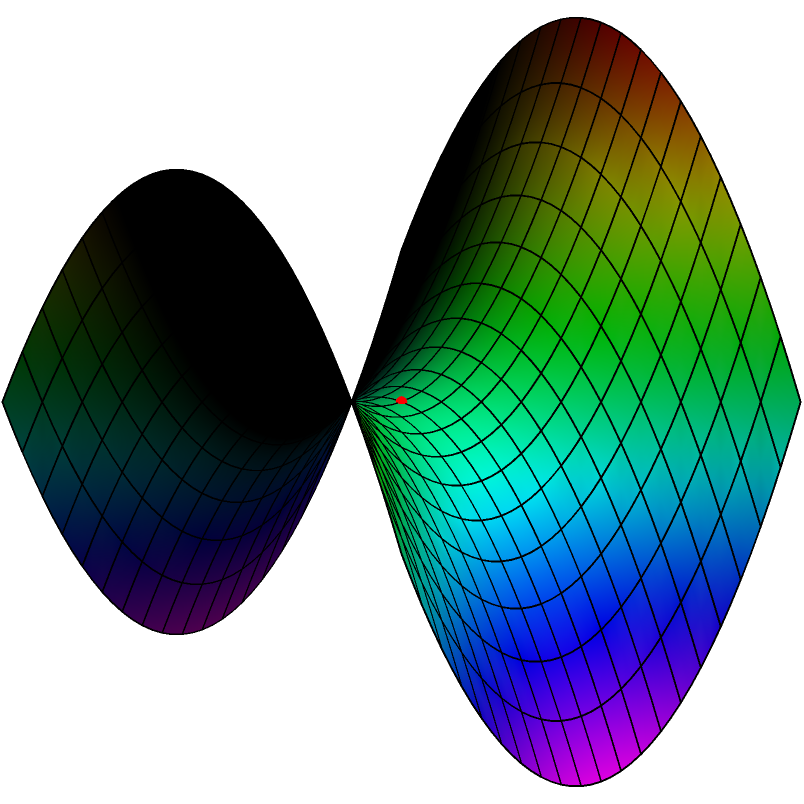On this saddle-shaped surface representing Mylène Farmer's career, point A (in red) represents her debut, and point B (in blue) represents her current status. Which path between these points would best symbolize her journey, considering the non-Euclidean geometry of her career trajectory? To answer this question, we need to consider the principles of non-Euclidean geometry on a saddle-shaped surface:

1. In non-Euclidean geometry, the shortest path between two points is not always a straight line.

2. On a saddle-shaped surface (hyperbolic paraboloid), the shortest path is a geodesic curve.

3. The saddle shape represents the ups and downs, twists and turns in Mylène Farmer's career.

4. The red dot (A) at the center represents her debut, while the blue dot (B) represents her current status.

5. The dashed red line on the surface represents the geodesic curve between points A and B.

6. This geodesic curve is not a straight line but follows the contours of the surface, symbolizing how Mylène Farmer's career path adapted to the "landscape" of the music industry.

7. The curve starts steep (rapid initial success) and then levels out (established career), reflecting Farmer's journey from a new artist to an iconic figure in French music.

8. The twists in the curve could represent various phases or reinventions in her career, such as her forays into different musical styles or her work in film.

Therefore, the geodesic curve (dashed red line) best symbolizes Mylène Farmer's career journey, as it represents the optimal path considering the non-Euclidean "landscape" of her career.
Answer: The geodesic curve (dashed red line) 